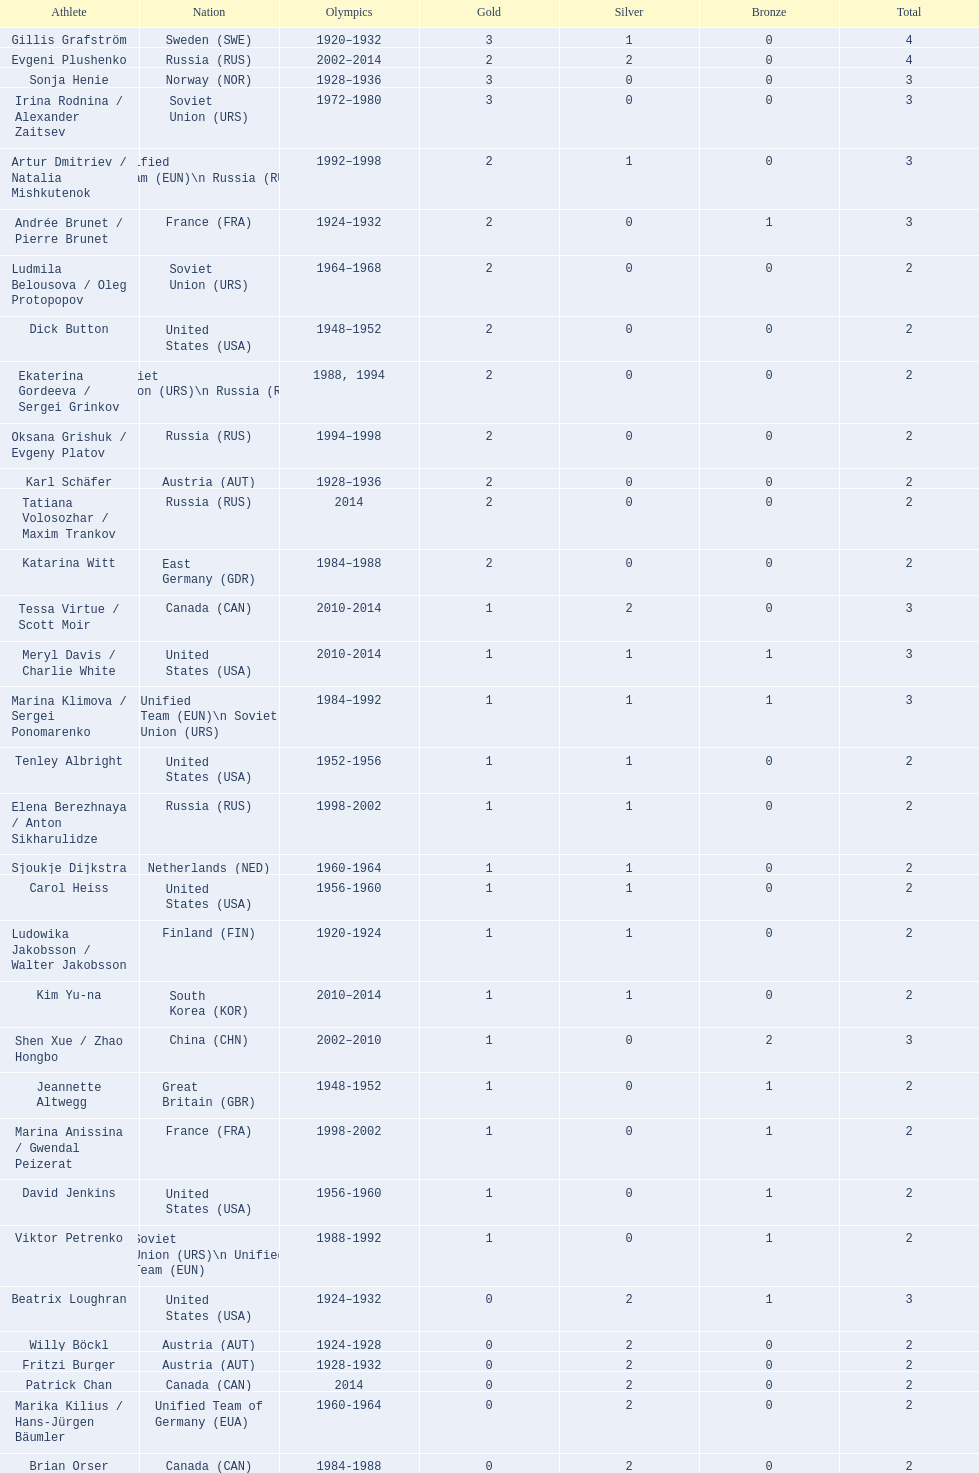How many medals have sweden and norway won combined? 7. Could you help me parse every detail presented in this table? {'header': ['Athlete', 'Nation', 'Olympics', 'Gold', 'Silver', 'Bronze', 'Total'], 'rows': [['Gillis Grafström', 'Sweden\xa0(SWE)', '1920–1932', '3', '1', '0', '4'], ['Evgeni Plushenko', 'Russia\xa0(RUS)', '2002–2014', '2', '2', '0', '4'], ['Sonja Henie', 'Norway\xa0(NOR)', '1928–1936', '3', '0', '0', '3'], ['Irina Rodnina / Alexander Zaitsev', 'Soviet Union\xa0(URS)', '1972–1980', '3', '0', '0', '3'], ['Artur Dmitriev / Natalia Mishkutenok', 'Unified Team\xa0(EUN)\\n\xa0Russia\xa0(RUS)', '1992–1998', '2', '1', '0', '3'], ['Andrée Brunet / Pierre Brunet', 'France\xa0(FRA)', '1924–1932', '2', '0', '1', '3'], ['Ludmila Belousova / Oleg Protopopov', 'Soviet Union\xa0(URS)', '1964–1968', '2', '0', '0', '2'], ['Dick Button', 'United States\xa0(USA)', '1948–1952', '2', '0', '0', '2'], ['Ekaterina Gordeeva / Sergei Grinkov', 'Soviet Union\xa0(URS)\\n\xa0Russia\xa0(RUS)', '1988, 1994', '2', '0', '0', '2'], ['Oksana Grishuk / Evgeny Platov', 'Russia\xa0(RUS)', '1994–1998', '2', '0', '0', '2'], ['Karl Schäfer', 'Austria\xa0(AUT)', '1928–1936', '2', '0', '0', '2'], ['Tatiana Volosozhar / Maxim Trankov', 'Russia\xa0(RUS)', '2014', '2', '0', '0', '2'], ['Katarina Witt', 'East Germany\xa0(GDR)', '1984–1988', '2', '0', '0', '2'], ['Tessa Virtue / Scott Moir', 'Canada\xa0(CAN)', '2010-2014', '1', '2', '0', '3'], ['Meryl Davis / Charlie White', 'United States\xa0(USA)', '2010-2014', '1', '1', '1', '3'], ['Marina Klimova / Sergei Ponomarenko', 'Unified Team\xa0(EUN)\\n\xa0Soviet Union\xa0(URS)', '1984–1992', '1', '1', '1', '3'], ['Tenley Albright', 'United States\xa0(USA)', '1952-1956', '1', '1', '0', '2'], ['Elena Berezhnaya / Anton Sikharulidze', 'Russia\xa0(RUS)', '1998-2002', '1', '1', '0', '2'], ['Sjoukje Dijkstra', 'Netherlands\xa0(NED)', '1960-1964', '1', '1', '0', '2'], ['Carol Heiss', 'United States\xa0(USA)', '1956-1960', '1', '1', '0', '2'], ['Ludowika Jakobsson / Walter Jakobsson', 'Finland\xa0(FIN)', '1920-1924', '1', '1', '0', '2'], ['Kim Yu-na', 'South Korea\xa0(KOR)', '2010–2014', '1', '1', '0', '2'], ['Shen Xue / Zhao Hongbo', 'China\xa0(CHN)', '2002–2010', '1', '0', '2', '3'], ['Jeannette Altwegg', 'Great Britain\xa0(GBR)', '1948-1952', '1', '0', '1', '2'], ['Marina Anissina / Gwendal Peizerat', 'France\xa0(FRA)', '1998-2002', '1', '0', '1', '2'], ['David Jenkins', 'United States\xa0(USA)', '1956-1960', '1', '0', '1', '2'], ['Viktor Petrenko', 'Soviet Union\xa0(URS)\\n\xa0Unified Team\xa0(EUN)', '1988-1992', '1', '0', '1', '2'], ['Beatrix Loughran', 'United States\xa0(USA)', '1924–1932', '0', '2', '1', '3'], ['Willy Böckl', 'Austria\xa0(AUT)', '1924-1928', '0', '2', '0', '2'], ['Fritzi Burger', 'Austria\xa0(AUT)', '1928-1932', '0', '2', '0', '2'], ['Patrick Chan', 'Canada\xa0(CAN)', '2014', '0', '2', '0', '2'], ['Marika Kilius / Hans-Jürgen Bäumler', 'Unified Team of Germany\xa0(EUA)', '1960-1964', '0', '2', '0', '2'], ['Brian Orser', 'Canada\xa0(CAN)', '1984-1988', '0', '2', '0', '2'], ['Elvis Stojko', 'Canada\xa0(CAN)', '1994-1998', '0', '2', '0', '2'], ['Phyllis Johnson', 'Great Britain\xa0(GBR)', '1908-1920', '0', '1', '1', '2'], ['Nancy Kerrigan', 'United States\xa0(USA)', '1992-1994', '0', '1', '1', '2'], ['Michelle Kwan', 'United States\xa0(USA)', '1998-2002', '0', '1', '1', '2'], ['Irina Slutskaya', 'Russia\xa0(RUS)', '2002-2006', '0', '1', '1', '2'], ['Maya Usova / Alexander Zhulin', 'Unified Team\xa0(EUN)\\n\xa0Russia\xa0(RUS)', '1992-1994', '0', '1', '1', '2'], ['Isabelle Brasseur / Lloyd Eisler', 'Canada\xa0(CAN)', '1992-1994', '0', '0', '2', '2'], ['Philippe Candeloro', 'France\xa0(FRA)', '1994-1998', '0', '0', '2', '2'], ['Manuela Groß / Uwe Kagelmann', 'East Germany\xa0(GDR)', '1972-1976', '0', '0', '2', '2'], ['Chen Lu', 'China\xa0(CHN)', '1994-1998', '0', '0', '2', '2'], ['Marianna Nagy / László Nagy', 'Hungary\xa0(HUN)', '1952-1956', '0', '0', '2', '2'], ['Patrick Péra', 'France\xa0(FRA)', '1968-1972', '0', '0', '2', '2'], ['Emília Rotter / László Szollás', 'Hungary\xa0(HUN)', '1932-1936', '0', '0', '2', '2'], ['Aliona Savchenko / Robin Szolkowy', 'Germany\xa0(GER)', '2010-2014', '0', '0', '2', '2']]} 